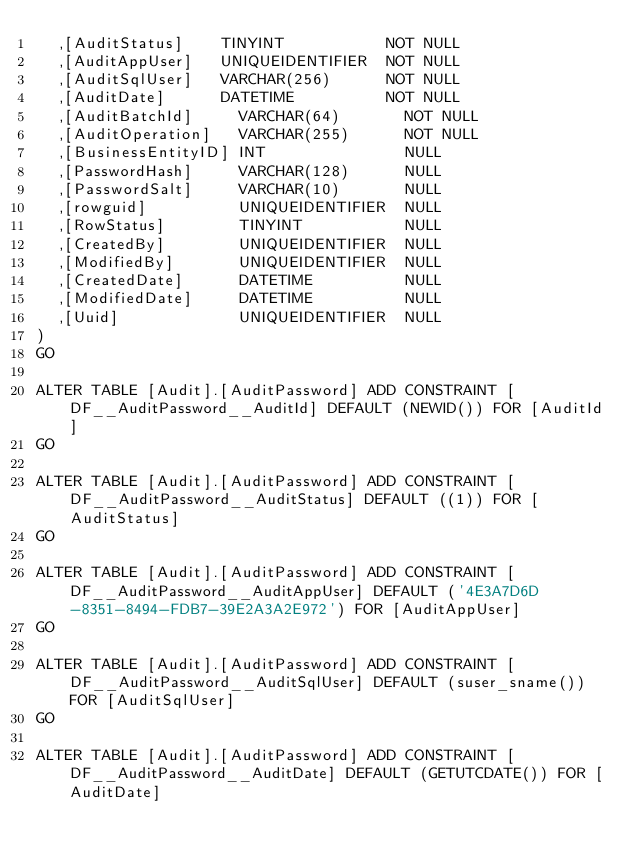<code> <loc_0><loc_0><loc_500><loc_500><_SQL_>  ,[AuditStatus]    TINYINT           NOT NULL
  ,[AuditAppUser]   UNIQUEIDENTIFIER  NOT NULL
  ,[AuditSqlUser]   VARCHAR(256)      NOT NULL
  ,[AuditDate]      DATETIME          NOT NULL
  ,[AuditBatchId]     VARCHAR(64)       NOT NULL
  ,[AuditOperation]   VARCHAR(255)      NOT NULL
  ,[BusinessEntityID] INT               NULL
  ,[PasswordHash]     VARCHAR(128)      NULL
  ,[PasswordSalt]     VARCHAR(10)       NULL
  ,[rowguid]          UNIQUEIDENTIFIER  NULL
  ,[RowStatus]        TINYINT           NULL
  ,[CreatedBy]        UNIQUEIDENTIFIER  NULL
  ,[ModifiedBy]       UNIQUEIDENTIFIER  NULL
  ,[CreatedDate]      DATETIME          NULL
  ,[ModifiedDate]     DATETIME          NULL
  ,[Uuid]             UNIQUEIDENTIFIER  NULL
)
GO

ALTER TABLE [Audit].[AuditPassword] ADD CONSTRAINT [DF__AuditPassword__AuditId] DEFAULT (NEWID()) FOR [AuditId]
GO

ALTER TABLE [Audit].[AuditPassword] ADD CONSTRAINT [DF__AuditPassword__AuditStatus] DEFAULT ((1)) FOR [AuditStatus]
GO

ALTER TABLE [Audit].[AuditPassword] ADD CONSTRAINT [DF__AuditPassword__AuditAppUser] DEFAULT ('4E3A7D6D-8351-8494-FDB7-39E2A3A2E972') FOR [AuditAppUser]
GO

ALTER TABLE [Audit].[AuditPassword] ADD CONSTRAINT [DF__AuditPassword__AuditSqlUser] DEFAULT (suser_sname()) FOR [AuditSqlUser]
GO

ALTER TABLE [Audit].[AuditPassword] ADD CONSTRAINT [DF__AuditPassword__AuditDate] DEFAULT (GETUTCDATE()) FOR [AuditDate]</code> 